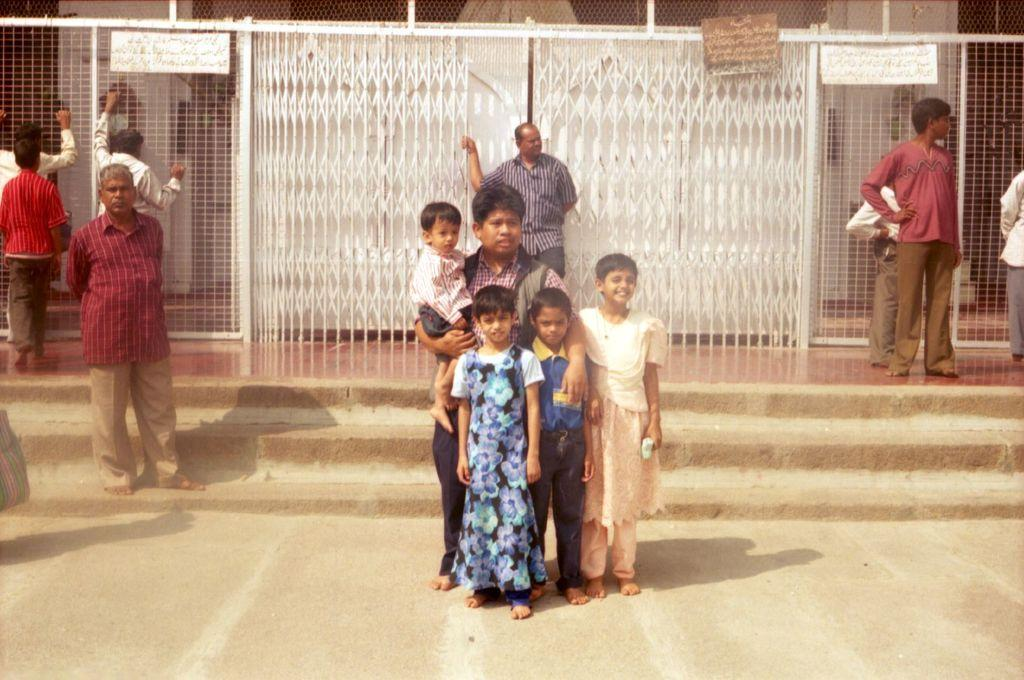How many people are standing on the ground in the image? There are four people standing on the ground in the image. Can you describe the background of the image? In the background, there are people, steps, a gate, a mesh, name boards, and some objects. What is the purpose of the gate in the background? The purpose of the gate in the background cannot be determined from the image alone. What type of objects can be seen in the background? Some objects can be seen in the background, but their specific nature cannot be determined from the image alone. How many boys are sitting on the mom's lap in the image? There are no boys or moms present in the image. What is inside the box that is visible in the image? There is no box visible in the image. 